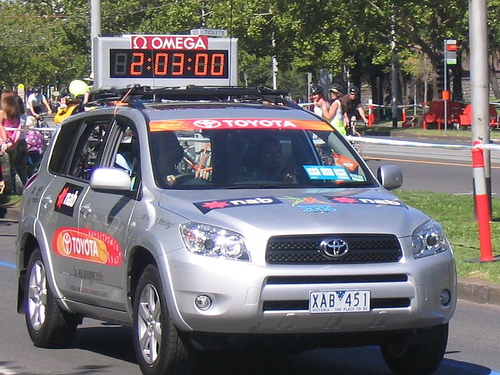Identify the text displayed in this image. OMEGA 2:03:00 TOYOTA TOYOTA XAB 451 8 